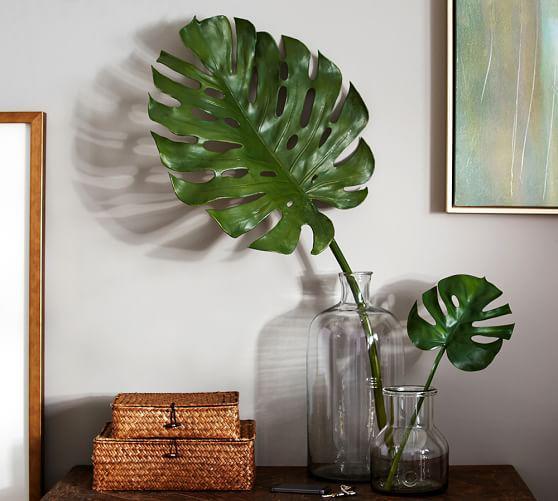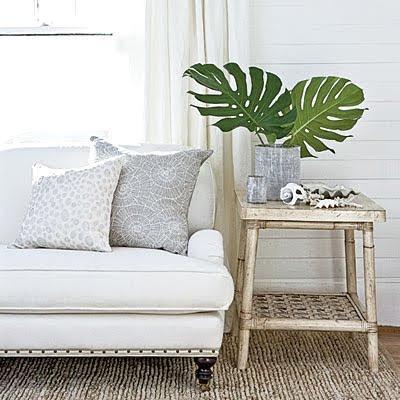The first image is the image on the left, the second image is the image on the right. Examine the images to the left and right. Is the description "The left and right image contains the same number of palm leaves." accurate? Answer yes or no. Yes. 